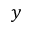<formula> <loc_0><loc_0><loc_500><loc_500>y</formula> 